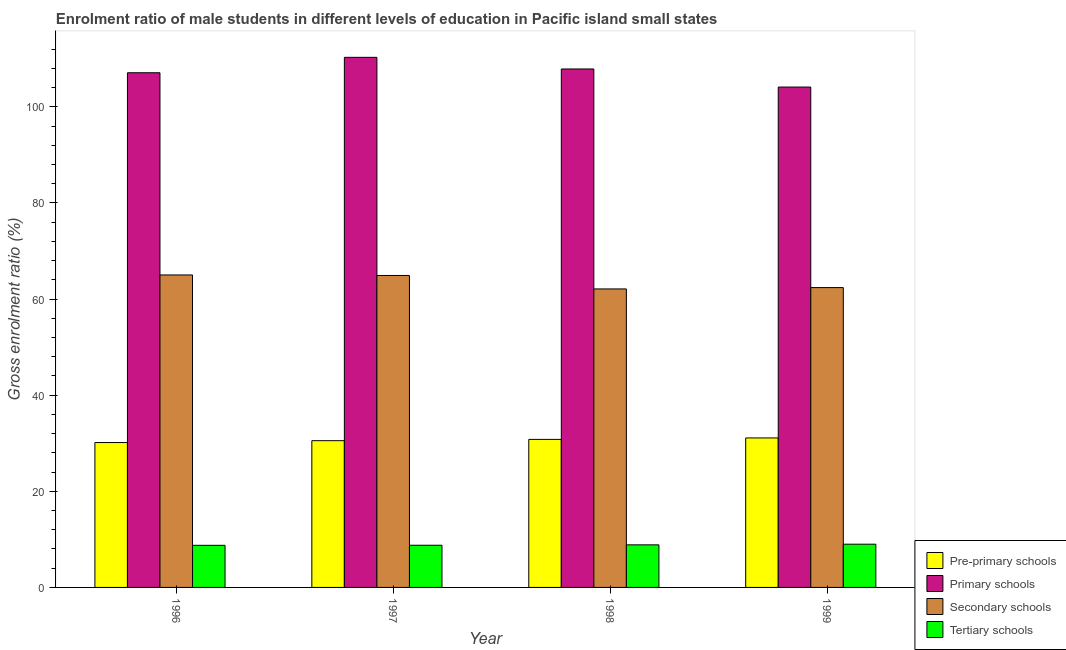How many different coloured bars are there?
Your answer should be very brief. 4. How many groups of bars are there?
Give a very brief answer. 4. Are the number of bars on each tick of the X-axis equal?
Offer a very short reply. Yes. What is the label of the 3rd group of bars from the left?
Provide a succinct answer. 1998. In how many cases, is the number of bars for a given year not equal to the number of legend labels?
Ensure brevity in your answer.  0. What is the gross enrolment ratio(female) in primary schools in 1999?
Make the answer very short. 104.12. Across all years, what is the maximum gross enrolment ratio(female) in pre-primary schools?
Your answer should be compact. 31.1. Across all years, what is the minimum gross enrolment ratio(female) in tertiary schools?
Offer a very short reply. 8.76. What is the total gross enrolment ratio(female) in tertiary schools in the graph?
Offer a very short reply. 35.39. What is the difference between the gross enrolment ratio(female) in primary schools in 1996 and that in 1997?
Keep it short and to the point. -3.21. What is the difference between the gross enrolment ratio(female) in pre-primary schools in 1997 and the gross enrolment ratio(female) in primary schools in 1996?
Your answer should be very brief. 0.39. What is the average gross enrolment ratio(female) in primary schools per year?
Make the answer very short. 107.35. In the year 1996, what is the difference between the gross enrolment ratio(female) in pre-primary schools and gross enrolment ratio(female) in tertiary schools?
Make the answer very short. 0. In how many years, is the gross enrolment ratio(female) in pre-primary schools greater than 16 %?
Your answer should be very brief. 4. What is the ratio of the gross enrolment ratio(female) in pre-primary schools in 1997 to that in 1999?
Your answer should be very brief. 0.98. Is the gross enrolment ratio(female) in secondary schools in 1996 less than that in 1997?
Your answer should be very brief. No. What is the difference between the highest and the second highest gross enrolment ratio(female) in secondary schools?
Give a very brief answer. 0.11. What is the difference between the highest and the lowest gross enrolment ratio(female) in primary schools?
Your response must be concise. 6.19. Is the sum of the gross enrolment ratio(female) in secondary schools in 1997 and 1999 greater than the maximum gross enrolment ratio(female) in primary schools across all years?
Your answer should be compact. Yes. Is it the case that in every year, the sum of the gross enrolment ratio(female) in primary schools and gross enrolment ratio(female) in secondary schools is greater than the sum of gross enrolment ratio(female) in tertiary schools and gross enrolment ratio(female) in pre-primary schools?
Offer a very short reply. No. What does the 3rd bar from the left in 1999 represents?
Offer a terse response. Secondary schools. What does the 1st bar from the right in 1996 represents?
Your answer should be very brief. Tertiary schools. Is it the case that in every year, the sum of the gross enrolment ratio(female) in pre-primary schools and gross enrolment ratio(female) in primary schools is greater than the gross enrolment ratio(female) in secondary schools?
Provide a succinct answer. Yes. Are all the bars in the graph horizontal?
Make the answer very short. No. Are the values on the major ticks of Y-axis written in scientific E-notation?
Give a very brief answer. No. Does the graph contain grids?
Give a very brief answer. No. How many legend labels are there?
Make the answer very short. 4. What is the title of the graph?
Keep it short and to the point. Enrolment ratio of male students in different levels of education in Pacific island small states. What is the Gross enrolment ratio (%) in Pre-primary schools in 1996?
Your answer should be compact. 30.15. What is the Gross enrolment ratio (%) of Primary schools in 1996?
Your response must be concise. 107.09. What is the Gross enrolment ratio (%) in Secondary schools in 1996?
Your response must be concise. 65.02. What is the Gross enrolment ratio (%) of Tertiary schools in 1996?
Your response must be concise. 8.76. What is the Gross enrolment ratio (%) of Pre-primary schools in 1997?
Provide a succinct answer. 30.53. What is the Gross enrolment ratio (%) of Primary schools in 1997?
Give a very brief answer. 110.3. What is the Gross enrolment ratio (%) of Secondary schools in 1997?
Provide a succinct answer. 64.91. What is the Gross enrolment ratio (%) in Tertiary schools in 1997?
Your response must be concise. 8.78. What is the Gross enrolment ratio (%) of Pre-primary schools in 1998?
Give a very brief answer. 30.8. What is the Gross enrolment ratio (%) of Primary schools in 1998?
Offer a terse response. 107.88. What is the Gross enrolment ratio (%) in Secondary schools in 1998?
Ensure brevity in your answer.  62.11. What is the Gross enrolment ratio (%) of Tertiary schools in 1998?
Offer a terse response. 8.86. What is the Gross enrolment ratio (%) in Pre-primary schools in 1999?
Your answer should be compact. 31.1. What is the Gross enrolment ratio (%) of Primary schools in 1999?
Provide a succinct answer. 104.12. What is the Gross enrolment ratio (%) in Secondary schools in 1999?
Your answer should be compact. 62.39. What is the Gross enrolment ratio (%) in Tertiary schools in 1999?
Offer a terse response. 8.99. Across all years, what is the maximum Gross enrolment ratio (%) in Pre-primary schools?
Offer a terse response. 31.1. Across all years, what is the maximum Gross enrolment ratio (%) in Primary schools?
Make the answer very short. 110.3. Across all years, what is the maximum Gross enrolment ratio (%) of Secondary schools?
Ensure brevity in your answer.  65.02. Across all years, what is the maximum Gross enrolment ratio (%) of Tertiary schools?
Your answer should be very brief. 8.99. Across all years, what is the minimum Gross enrolment ratio (%) in Pre-primary schools?
Give a very brief answer. 30.15. Across all years, what is the minimum Gross enrolment ratio (%) of Primary schools?
Your answer should be very brief. 104.12. Across all years, what is the minimum Gross enrolment ratio (%) of Secondary schools?
Provide a succinct answer. 62.11. Across all years, what is the minimum Gross enrolment ratio (%) of Tertiary schools?
Give a very brief answer. 8.76. What is the total Gross enrolment ratio (%) in Pre-primary schools in the graph?
Offer a terse response. 122.58. What is the total Gross enrolment ratio (%) in Primary schools in the graph?
Your answer should be compact. 429.39. What is the total Gross enrolment ratio (%) in Secondary schools in the graph?
Provide a short and direct response. 254.43. What is the total Gross enrolment ratio (%) in Tertiary schools in the graph?
Give a very brief answer. 35.39. What is the difference between the Gross enrolment ratio (%) of Pre-primary schools in 1996 and that in 1997?
Make the answer very short. -0.39. What is the difference between the Gross enrolment ratio (%) in Primary schools in 1996 and that in 1997?
Your answer should be very brief. -3.21. What is the difference between the Gross enrolment ratio (%) of Secondary schools in 1996 and that in 1997?
Offer a terse response. 0.11. What is the difference between the Gross enrolment ratio (%) of Tertiary schools in 1996 and that in 1997?
Make the answer very short. -0.02. What is the difference between the Gross enrolment ratio (%) of Pre-primary schools in 1996 and that in 1998?
Your response must be concise. -0.66. What is the difference between the Gross enrolment ratio (%) of Primary schools in 1996 and that in 1998?
Provide a succinct answer. -0.79. What is the difference between the Gross enrolment ratio (%) of Secondary schools in 1996 and that in 1998?
Offer a very short reply. 2.91. What is the difference between the Gross enrolment ratio (%) of Tertiary schools in 1996 and that in 1998?
Keep it short and to the point. -0.1. What is the difference between the Gross enrolment ratio (%) in Pre-primary schools in 1996 and that in 1999?
Your response must be concise. -0.96. What is the difference between the Gross enrolment ratio (%) in Primary schools in 1996 and that in 1999?
Offer a very short reply. 2.98. What is the difference between the Gross enrolment ratio (%) in Secondary schools in 1996 and that in 1999?
Your response must be concise. 2.63. What is the difference between the Gross enrolment ratio (%) of Tertiary schools in 1996 and that in 1999?
Your response must be concise. -0.23. What is the difference between the Gross enrolment ratio (%) in Pre-primary schools in 1997 and that in 1998?
Your answer should be very brief. -0.27. What is the difference between the Gross enrolment ratio (%) in Primary schools in 1997 and that in 1998?
Your answer should be very brief. 2.42. What is the difference between the Gross enrolment ratio (%) in Secondary schools in 1997 and that in 1998?
Provide a short and direct response. 2.8. What is the difference between the Gross enrolment ratio (%) of Tertiary schools in 1997 and that in 1998?
Your response must be concise. -0.08. What is the difference between the Gross enrolment ratio (%) of Pre-primary schools in 1997 and that in 1999?
Provide a short and direct response. -0.57. What is the difference between the Gross enrolment ratio (%) in Primary schools in 1997 and that in 1999?
Keep it short and to the point. 6.19. What is the difference between the Gross enrolment ratio (%) of Secondary schools in 1997 and that in 1999?
Your answer should be very brief. 2.52. What is the difference between the Gross enrolment ratio (%) in Tertiary schools in 1997 and that in 1999?
Make the answer very short. -0.22. What is the difference between the Gross enrolment ratio (%) in Pre-primary schools in 1998 and that in 1999?
Make the answer very short. -0.3. What is the difference between the Gross enrolment ratio (%) of Primary schools in 1998 and that in 1999?
Ensure brevity in your answer.  3.76. What is the difference between the Gross enrolment ratio (%) of Secondary schools in 1998 and that in 1999?
Your response must be concise. -0.28. What is the difference between the Gross enrolment ratio (%) of Tertiary schools in 1998 and that in 1999?
Offer a terse response. -0.13. What is the difference between the Gross enrolment ratio (%) of Pre-primary schools in 1996 and the Gross enrolment ratio (%) of Primary schools in 1997?
Offer a very short reply. -80.16. What is the difference between the Gross enrolment ratio (%) of Pre-primary schools in 1996 and the Gross enrolment ratio (%) of Secondary schools in 1997?
Your response must be concise. -34.77. What is the difference between the Gross enrolment ratio (%) of Pre-primary schools in 1996 and the Gross enrolment ratio (%) of Tertiary schools in 1997?
Offer a very short reply. 21.37. What is the difference between the Gross enrolment ratio (%) in Primary schools in 1996 and the Gross enrolment ratio (%) in Secondary schools in 1997?
Keep it short and to the point. 42.18. What is the difference between the Gross enrolment ratio (%) of Primary schools in 1996 and the Gross enrolment ratio (%) of Tertiary schools in 1997?
Your answer should be compact. 98.32. What is the difference between the Gross enrolment ratio (%) of Secondary schools in 1996 and the Gross enrolment ratio (%) of Tertiary schools in 1997?
Make the answer very short. 56.24. What is the difference between the Gross enrolment ratio (%) in Pre-primary schools in 1996 and the Gross enrolment ratio (%) in Primary schools in 1998?
Your response must be concise. -77.73. What is the difference between the Gross enrolment ratio (%) of Pre-primary schools in 1996 and the Gross enrolment ratio (%) of Secondary schools in 1998?
Offer a terse response. -31.97. What is the difference between the Gross enrolment ratio (%) of Pre-primary schools in 1996 and the Gross enrolment ratio (%) of Tertiary schools in 1998?
Offer a very short reply. 21.29. What is the difference between the Gross enrolment ratio (%) in Primary schools in 1996 and the Gross enrolment ratio (%) in Secondary schools in 1998?
Keep it short and to the point. 44.98. What is the difference between the Gross enrolment ratio (%) of Primary schools in 1996 and the Gross enrolment ratio (%) of Tertiary schools in 1998?
Make the answer very short. 98.23. What is the difference between the Gross enrolment ratio (%) of Secondary schools in 1996 and the Gross enrolment ratio (%) of Tertiary schools in 1998?
Your response must be concise. 56.16. What is the difference between the Gross enrolment ratio (%) in Pre-primary schools in 1996 and the Gross enrolment ratio (%) in Primary schools in 1999?
Offer a very short reply. -73.97. What is the difference between the Gross enrolment ratio (%) in Pre-primary schools in 1996 and the Gross enrolment ratio (%) in Secondary schools in 1999?
Give a very brief answer. -32.25. What is the difference between the Gross enrolment ratio (%) of Pre-primary schools in 1996 and the Gross enrolment ratio (%) of Tertiary schools in 1999?
Make the answer very short. 21.15. What is the difference between the Gross enrolment ratio (%) in Primary schools in 1996 and the Gross enrolment ratio (%) in Secondary schools in 1999?
Give a very brief answer. 44.7. What is the difference between the Gross enrolment ratio (%) in Primary schools in 1996 and the Gross enrolment ratio (%) in Tertiary schools in 1999?
Your answer should be very brief. 98.1. What is the difference between the Gross enrolment ratio (%) in Secondary schools in 1996 and the Gross enrolment ratio (%) in Tertiary schools in 1999?
Your response must be concise. 56.02. What is the difference between the Gross enrolment ratio (%) in Pre-primary schools in 1997 and the Gross enrolment ratio (%) in Primary schools in 1998?
Give a very brief answer. -77.35. What is the difference between the Gross enrolment ratio (%) in Pre-primary schools in 1997 and the Gross enrolment ratio (%) in Secondary schools in 1998?
Provide a succinct answer. -31.58. What is the difference between the Gross enrolment ratio (%) of Pre-primary schools in 1997 and the Gross enrolment ratio (%) of Tertiary schools in 1998?
Provide a short and direct response. 21.67. What is the difference between the Gross enrolment ratio (%) in Primary schools in 1997 and the Gross enrolment ratio (%) in Secondary schools in 1998?
Make the answer very short. 48.19. What is the difference between the Gross enrolment ratio (%) of Primary schools in 1997 and the Gross enrolment ratio (%) of Tertiary schools in 1998?
Offer a very short reply. 101.44. What is the difference between the Gross enrolment ratio (%) in Secondary schools in 1997 and the Gross enrolment ratio (%) in Tertiary schools in 1998?
Your answer should be compact. 56.05. What is the difference between the Gross enrolment ratio (%) of Pre-primary schools in 1997 and the Gross enrolment ratio (%) of Primary schools in 1999?
Your answer should be compact. -73.58. What is the difference between the Gross enrolment ratio (%) in Pre-primary schools in 1997 and the Gross enrolment ratio (%) in Secondary schools in 1999?
Provide a succinct answer. -31.86. What is the difference between the Gross enrolment ratio (%) of Pre-primary schools in 1997 and the Gross enrolment ratio (%) of Tertiary schools in 1999?
Provide a succinct answer. 21.54. What is the difference between the Gross enrolment ratio (%) in Primary schools in 1997 and the Gross enrolment ratio (%) in Secondary schools in 1999?
Your answer should be very brief. 47.91. What is the difference between the Gross enrolment ratio (%) in Primary schools in 1997 and the Gross enrolment ratio (%) in Tertiary schools in 1999?
Your answer should be very brief. 101.31. What is the difference between the Gross enrolment ratio (%) of Secondary schools in 1997 and the Gross enrolment ratio (%) of Tertiary schools in 1999?
Give a very brief answer. 55.92. What is the difference between the Gross enrolment ratio (%) of Pre-primary schools in 1998 and the Gross enrolment ratio (%) of Primary schools in 1999?
Give a very brief answer. -73.32. What is the difference between the Gross enrolment ratio (%) of Pre-primary schools in 1998 and the Gross enrolment ratio (%) of Secondary schools in 1999?
Your response must be concise. -31.59. What is the difference between the Gross enrolment ratio (%) of Pre-primary schools in 1998 and the Gross enrolment ratio (%) of Tertiary schools in 1999?
Your response must be concise. 21.81. What is the difference between the Gross enrolment ratio (%) of Primary schools in 1998 and the Gross enrolment ratio (%) of Secondary schools in 1999?
Your answer should be very brief. 45.49. What is the difference between the Gross enrolment ratio (%) in Primary schools in 1998 and the Gross enrolment ratio (%) in Tertiary schools in 1999?
Give a very brief answer. 98.89. What is the difference between the Gross enrolment ratio (%) of Secondary schools in 1998 and the Gross enrolment ratio (%) of Tertiary schools in 1999?
Offer a terse response. 53.12. What is the average Gross enrolment ratio (%) of Pre-primary schools per year?
Give a very brief answer. 30.65. What is the average Gross enrolment ratio (%) of Primary schools per year?
Give a very brief answer. 107.35. What is the average Gross enrolment ratio (%) of Secondary schools per year?
Give a very brief answer. 63.61. What is the average Gross enrolment ratio (%) in Tertiary schools per year?
Ensure brevity in your answer.  8.85. In the year 1996, what is the difference between the Gross enrolment ratio (%) of Pre-primary schools and Gross enrolment ratio (%) of Primary schools?
Offer a terse response. -76.95. In the year 1996, what is the difference between the Gross enrolment ratio (%) in Pre-primary schools and Gross enrolment ratio (%) in Secondary schools?
Offer a terse response. -34.87. In the year 1996, what is the difference between the Gross enrolment ratio (%) of Pre-primary schools and Gross enrolment ratio (%) of Tertiary schools?
Ensure brevity in your answer.  21.39. In the year 1996, what is the difference between the Gross enrolment ratio (%) of Primary schools and Gross enrolment ratio (%) of Secondary schools?
Give a very brief answer. 42.08. In the year 1996, what is the difference between the Gross enrolment ratio (%) of Primary schools and Gross enrolment ratio (%) of Tertiary schools?
Make the answer very short. 98.33. In the year 1996, what is the difference between the Gross enrolment ratio (%) of Secondary schools and Gross enrolment ratio (%) of Tertiary schools?
Your answer should be compact. 56.26. In the year 1997, what is the difference between the Gross enrolment ratio (%) of Pre-primary schools and Gross enrolment ratio (%) of Primary schools?
Provide a short and direct response. -79.77. In the year 1997, what is the difference between the Gross enrolment ratio (%) of Pre-primary schools and Gross enrolment ratio (%) of Secondary schools?
Your answer should be very brief. -34.38. In the year 1997, what is the difference between the Gross enrolment ratio (%) in Pre-primary schools and Gross enrolment ratio (%) in Tertiary schools?
Your response must be concise. 21.76. In the year 1997, what is the difference between the Gross enrolment ratio (%) in Primary schools and Gross enrolment ratio (%) in Secondary schools?
Keep it short and to the point. 45.39. In the year 1997, what is the difference between the Gross enrolment ratio (%) of Primary schools and Gross enrolment ratio (%) of Tertiary schools?
Your answer should be very brief. 101.53. In the year 1997, what is the difference between the Gross enrolment ratio (%) of Secondary schools and Gross enrolment ratio (%) of Tertiary schools?
Keep it short and to the point. 56.13. In the year 1998, what is the difference between the Gross enrolment ratio (%) in Pre-primary schools and Gross enrolment ratio (%) in Primary schools?
Keep it short and to the point. -77.08. In the year 1998, what is the difference between the Gross enrolment ratio (%) in Pre-primary schools and Gross enrolment ratio (%) in Secondary schools?
Give a very brief answer. -31.31. In the year 1998, what is the difference between the Gross enrolment ratio (%) in Pre-primary schools and Gross enrolment ratio (%) in Tertiary schools?
Make the answer very short. 21.94. In the year 1998, what is the difference between the Gross enrolment ratio (%) in Primary schools and Gross enrolment ratio (%) in Secondary schools?
Offer a terse response. 45.77. In the year 1998, what is the difference between the Gross enrolment ratio (%) in Primary schools and Gross enrolment ratio (%) in Tertiary schools?
Offer a terse response. 99.02. In the year 1998, what is the difference between the Gross enrolment ratio (%) of Secondary schools and Gross enrolment ratio (%) of Tertiary schools?
Keep it short and to the point. 53.25. In the year 1999, what is the difference between the Gross enrolment ratio (%) in Pre-primary schools and Gross enrolment ratio (%) in Primary schools?
Your response must be concise. -73.01. In the year 1999, what is the difference between the Gross enrolment ratio (%) of Pre-primary schools and Gross enrolment ratio (%) of Secondary schools?
Your answer should be compact. -31.29. In the year 1999, what is the difference between the Gross enrolment ratio (%) in Pre-primary schools and Gross enrolment ratio (%) in Tertiary schools?
Keep it short and to the point. 22.11. In the year 1999, what is the difference between the Gross enrolment ratio (%) in Primary schools and Gross enrolment ratio (%) in Secondary schools?
Offer a terse response. 41.72. In the year 1999, what is the difference between the Gross enrolment ratio (%) in Primary schools and Gross enrolment ratio (%) in Tertiary schools?
Give a very brief answer. 95.12. In the year 1999, what is the difference between the Gross enrolment ratio (%) of Secondary schools and Gross enrolment ratio (%) of Tertiary schools?
Your response must be concise. 53.4. What is the ratio of the Gross enrolment ratio (%) of Pre-primary schools in 1996 to that in 1997?
Provide a short and direct response. 0.99. What is the ratio of the Gross enrolment ratio (%) of Primary schools in 1996 to that in 1997?
Give a very brief answer. 0.97. What is the ratio of the Gross enrolment ratio (%) in Pre-primary schools in 1996 to that in 1998?
Give a very brief answer. 0.98. What is the ratio of the Gross enrolment ratio (%) of Primary schools in 1996 to that in 1998?
Provide a short and direct response. 0.99. What is the ratio of the Gross enrolment ratio (%) in Secondary schools in 1996 to that in 1998?
Your answer should be compact. 1.05. What is the ratio of the Gross enrolment ratio (%) of Tertiary schools in 1996 to that in 1998?
Ensure brevity in your answer.  0.99. What is the ratio of the Gross enrolment ratio (%) of Pre-primary schools in 1996 to that in 1999?
Keep it short and to the point. 0.97. What is the ratio of the Gross enrolment ratio (%) of Primary schools in 1996 to that in 1999?
Keep it short and to the point. 1.03. What is the ratio of the Gross enrolment ratio (%) of Secondary schools in 1996 to that in 1999?
Provide a short and direct response. 1.04. What is the ratio of the Gross enrolment ratio (%) in Tertiary schools in 1996 to that in 1999?
Offer a terse response. 0.97. What is the ratio of the Gross enrolment ratio (%) in Primary schools in 1997 to that in 1998?
Provide a succinct answer. 1.02. What is the ratio of the Gross enrolment ratio (%) of Secondary schools in 1997 to that in 1998?
Keep it short and to the point. 1.05. What is the ratio of the Gross enrolment ratio (%) in Tertiary schools in 1997 to that in 1998?
Offer a terse response. 0.99. What is the ratio of the Gross enrolment ratio (%) in Pre-primary schools in 1997 to that in 1999?
Provide a short and direct response. 0.98. What is the ratio of the Gross enrolment ratio (%) in Primary schools in 1997 to that in 1999?
Make the answer very short. 1.06. What is the ratio of the Gross enrolment ratio (%) of Secondary schools in 1997 to that in 1999?
Keep it short and to the point. 1.04. What is the ratio of the Gross enrolment ratio (%) in Tertiary schools in 1997 to that in 1999?
Keep it short and to the point. 0.98. What is the ratio of the Gross enrolment ratio (%) in Pre-primary schools in 1998 to that in 1999?
Your response must be concise. 0.99. What is the ratio of the Gross enrolment ratio (%) in Primary schools in 1998 to that in 1999?
Your answer should be very brief. 1.04. What is the ratio of the Gross enrolment ratio (%) in Tertiary schools in 1998 to that in 1999?
Provide a succinct answer. 0.98. What is the difference between the highest and the second highest Gross enrolment ratio (%) of Pre-primary schools?
Ensure brevity in your answer.  0.3. What is the difference between the highest and the second highest Gross enrolment ratio (%) of Primary schools?
Keep it short and to the point. 2.42. What is the difference between the highest and the second highest Gross enrolment ratio (%) of Secondary schools?
Keep it short and to the point. 0.11. What is the difference between the highest and the second highest Gross enrolment ratio (%) in Tertiary schools?
Give a very brief answer. 0.13. What is the difference between the highest and the lowest Gross enrolment ratio (%) in Pre-primary schools?
Your response must be concise. 0.96. What is the difference between the highest and the lowest Gross enrolment ratio (%) of Primary schools?
Offer a terse response. 6.19. What is the difference between the highest and the lowest Gross enrolment ratio (%) in Secondary schools?
Make the answer very short. 2.91. What is the difference between the highest and the lowest Gross enrolment ratio (%) of Tertiary schools?
Offer a very short reply. 0.23. 